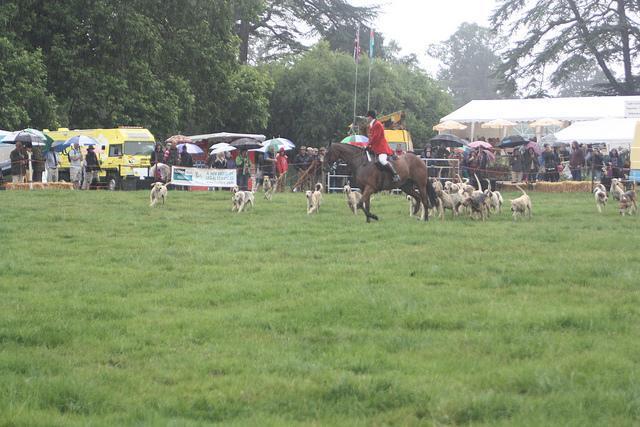How many dogs are there?
Give a very brief answer. 1. How many trucks are there?
Give a very brief answer. 1. 